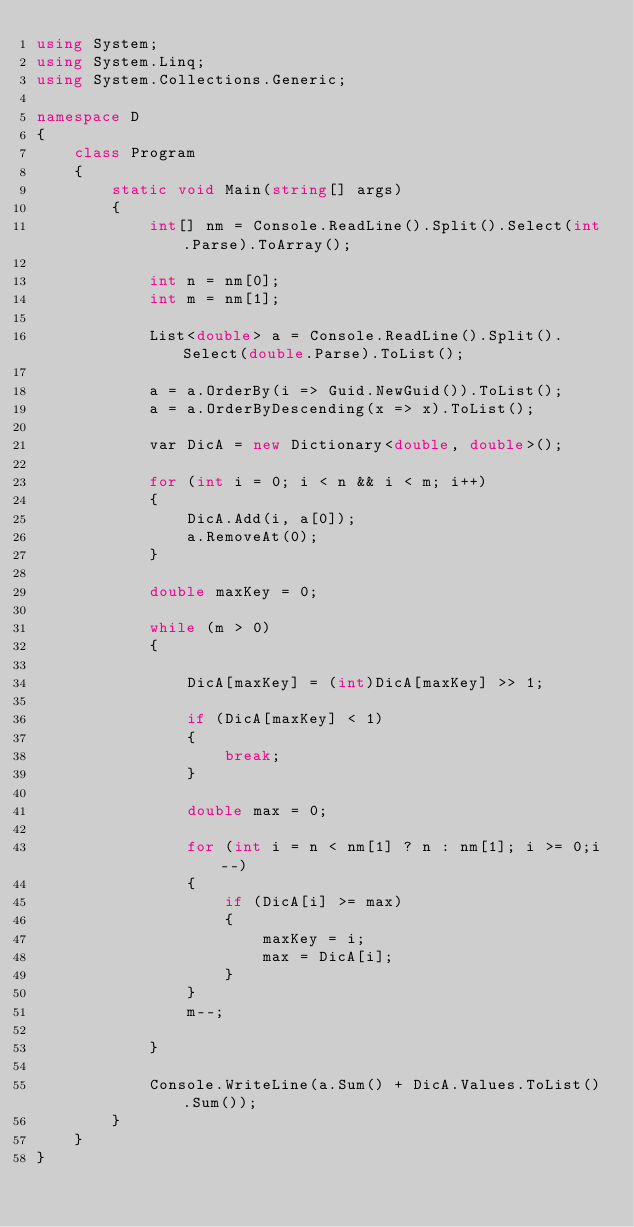Convert code to text. <code><loc_0><loc_0><loc_500><loc_500><_C#_>using System;
using System.Linq;
using System.Collections.Generic;

namespace D
{
    class Program
    {
        static void Main(string[] args)
        {
            int[] nm = Console.ReadLine().Split().Select(int.Parse).ToArray();

            int n = nm[0];
            int m = nm[1];

            List<double> a = Console.ReadLine().Split().Select(double.Parse).ToList();

            a = a.OrderBy(i => Guid.NewGuid()).ToList();
            a = a.OrderByDescending(x => x).ToList();

            var DicA = new Dictionary<double, double>();

            for (int i = 0; i < n && i < m; i++)
            {
                DicA.Add(i, a[0]);
                a.RemoveAt(0);
            }

            double maxKey = 0;

            while (m > 0)
            {

                DicA[maxKey] = (int)DicA[maxKey] >> 1;

                if (DicA[maxKey] < 1)
                {
                    break;
                }

                double max = 0;

                for (int i = n < nm[1] ? n : nm[1]; i >= 0;i--)
                {
                    if (DicA[i] >= max)
                    {
                        maxKey = i;
                        max = DicA[i];
                    }
                }
                m--;

            }

            Console.WriteLine(a.Sum() + DicA.Values.ToList().Sum());
        }
    }
}
</code> 